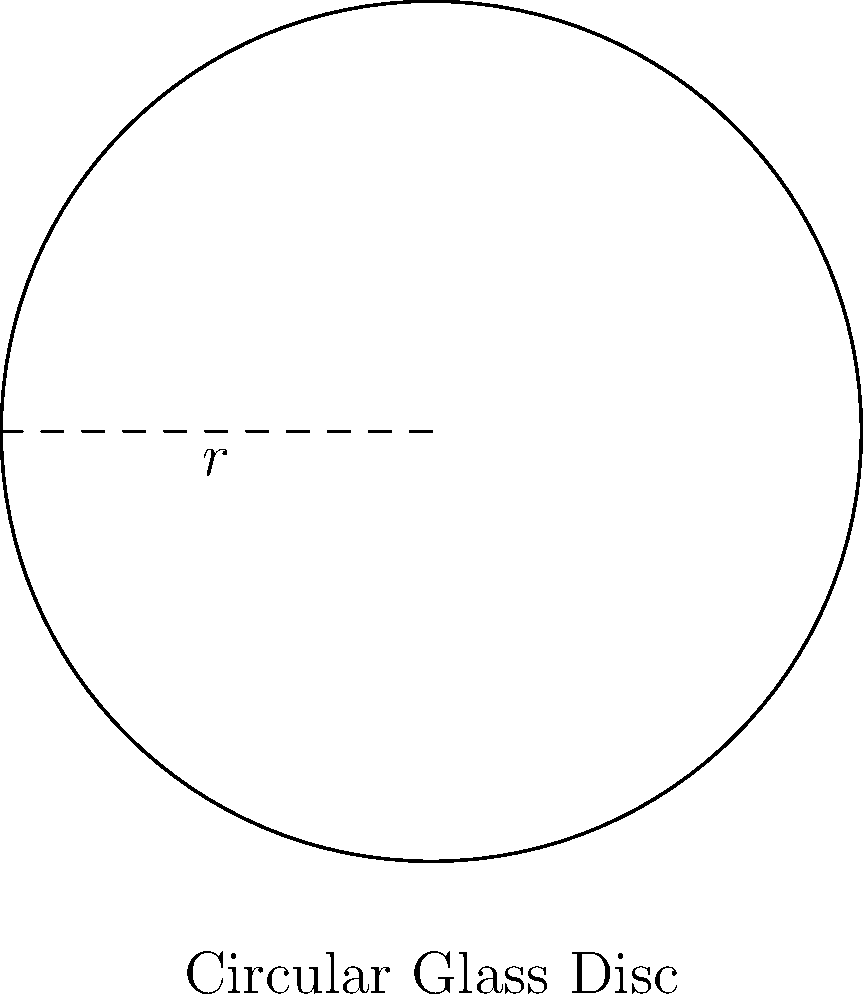A high-precision industrial glass manufacturer produces circular glass discs for optical instruments. The radius of each disc is 15 cm. If the production line needs to create 100 such discs, what is the total surface area of glass required, in square meters? To solve this problem, we'll follow these steps:

1) First, recall the formula for the area of a circle:
   $A = \pi r^2$

2) We're given that the radius (r) is 15 cm. Let's substitute this into our formula:
   $A = \pi (15\text{ cm})^2$

3) Simplify:
   $A = \pi (225\text{ cm}^2)$
   $A = 225\pi\text{ cm}^2$

4) Calculate this value (use 3.14159 for π):
   $A \approx 706.86\text{ cm}^2$

5) Now, we need to multiply this by 100 to get the total area for all discs:
   $\text{Total Area} = 100 \times 706.86\text{ cm}^2 = 70,686\text{ cm}^2$

6) Finally, we need to convert this to square meters. Recall that 1 m = 100 cm, so 1 m² = 10,000 cm²:
   $70,686\text{ cm}^2 = 70,686 \div 10,000 = 7.0686\text{ m}^2$

Therefore, the total surface area required is approximately 7.0686 m².
Answer: $7.0686\text{ m}^2$ 